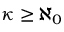<formula> <loc_0><loc_0><loc_500><loc_500>\kappa \geq \aleph _ { 0 }</formula> 